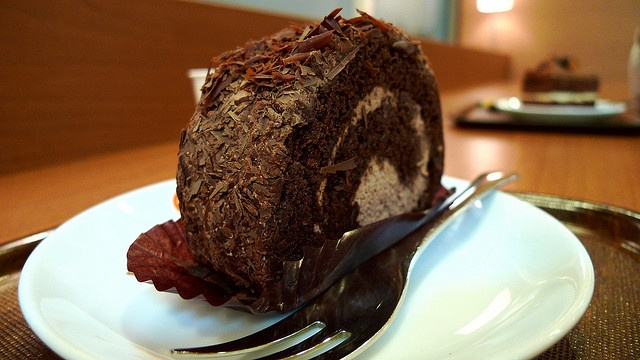Describe the objects in this image and their specific colors. I can see cake in maroon, black, and gray tones, fork in maroon, black, ivory, tan, and darkgray tones, and cake in maroon and brown tones in this image. 